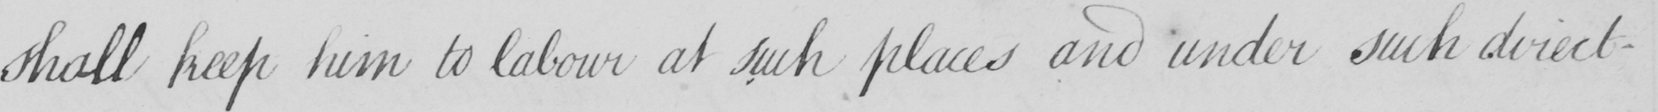What text is written in this handwritten line? shall keep him to labour at such places and under such directi- 